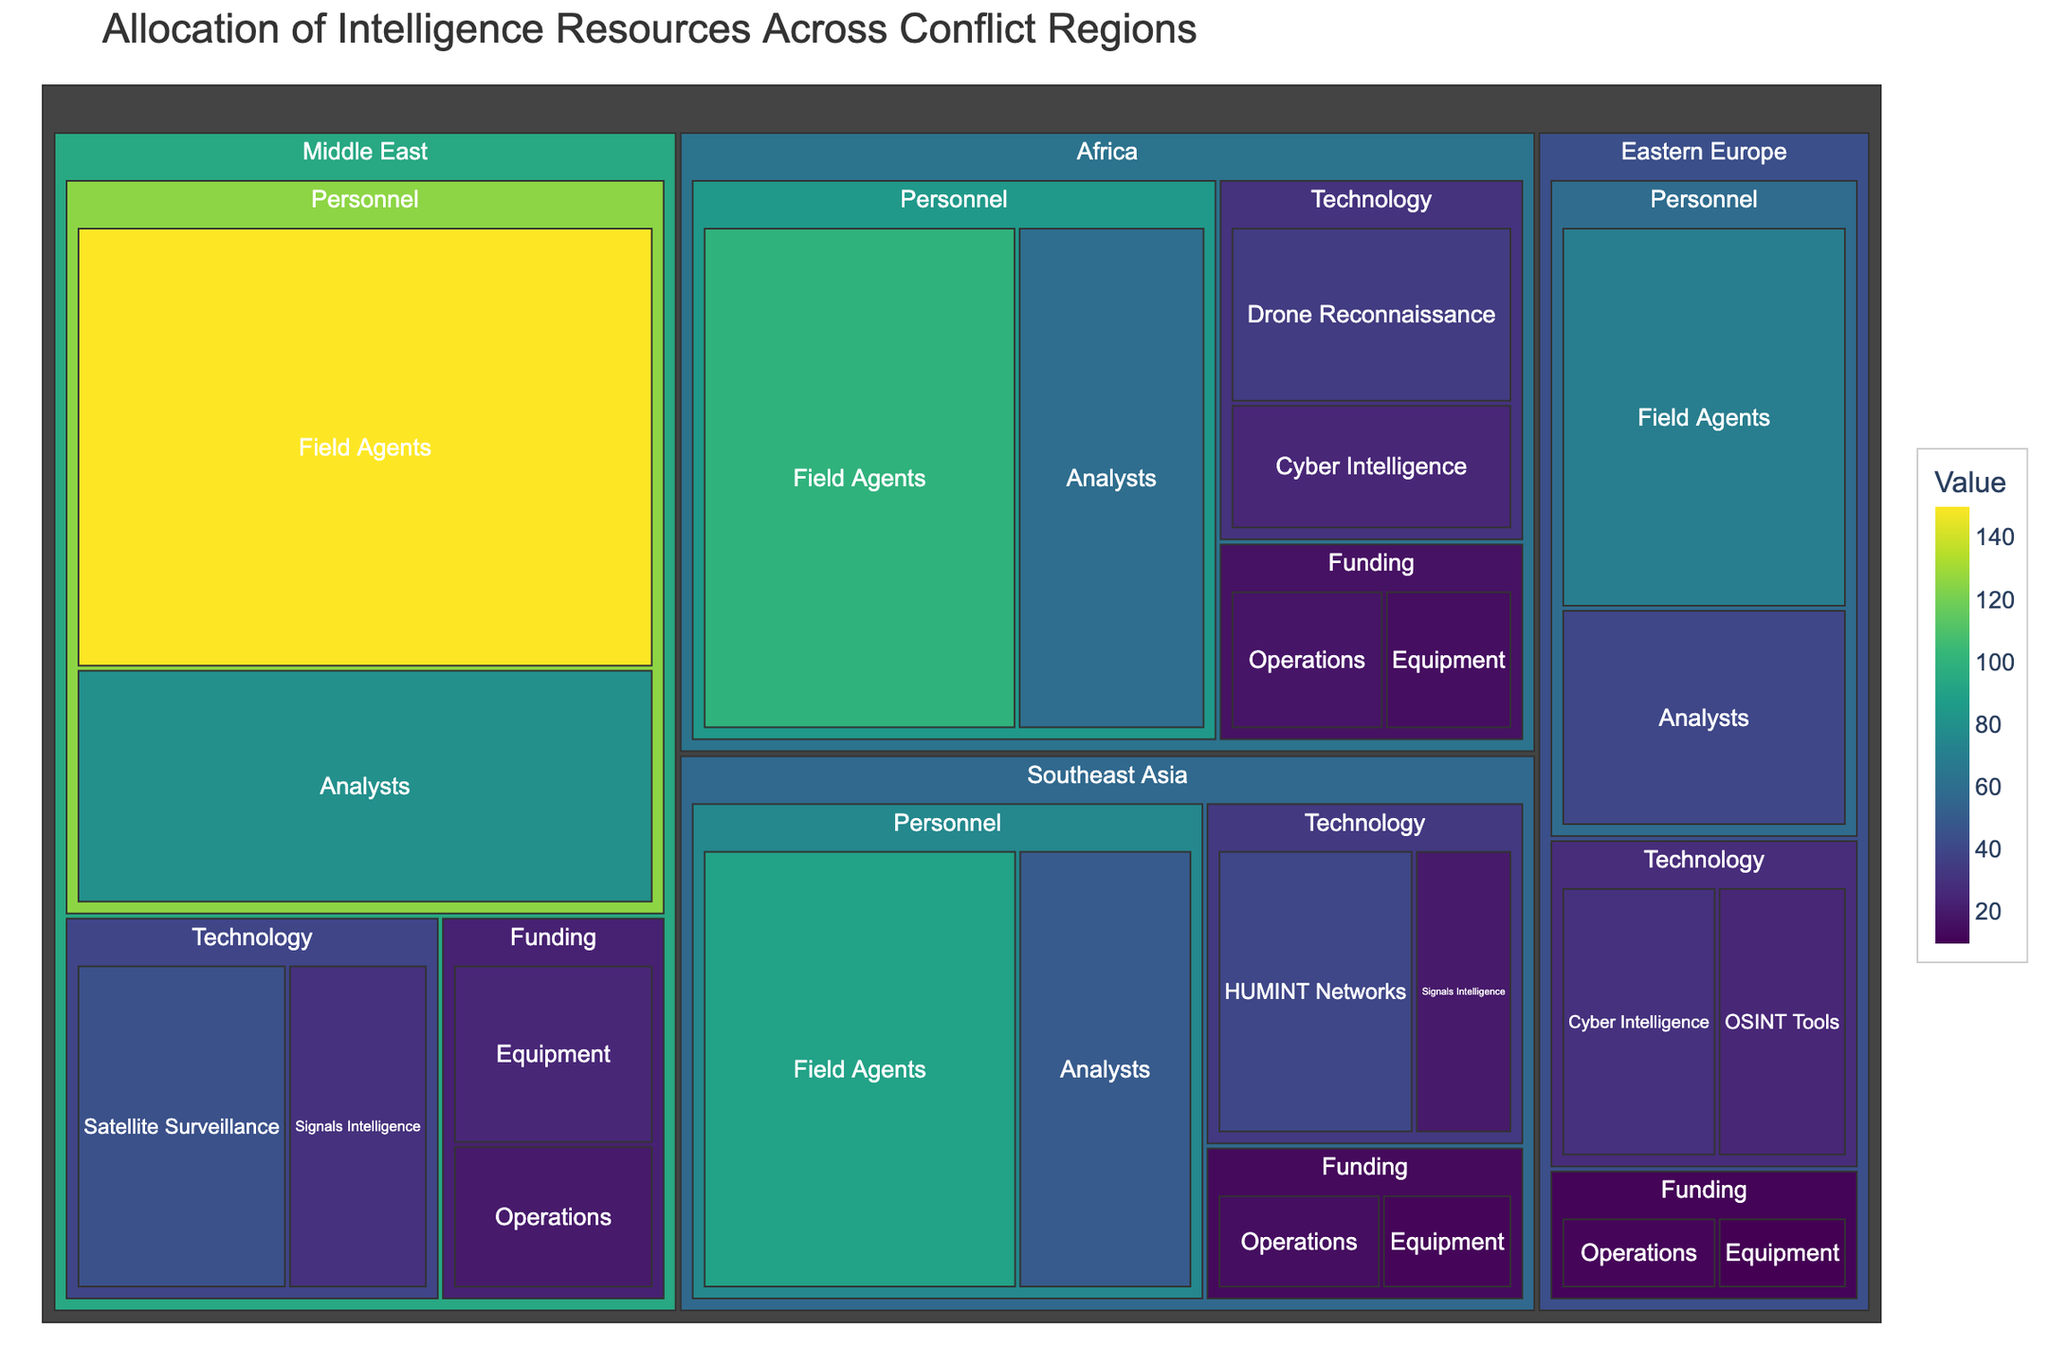What is the title of the treemap? The title of the figure is typically displayed at the top and provides a concise description of the content. Here, the title "Allocation of Intelligence Resources Across Conflict Regions" clearly explains what the figure represents.
Answer: Allocation of Intelligence Resources Across Conflict Regions What is the total value of personnel resources allocated in the Middle East? To determine this, sum the values of all personnel subcategories in the Middle East region: Field Agents (150) + Analysts (80).
Answer: 230 Which region has the highest allocation for Satellite Surveillance? By examining the 'Technology' category in each region, it's evident that only the Middle East has an allocation for Satellite Surveillance at 45.
Answer: Middle East Is the funding for operations in Southeast Asia higher or lower than in Africa? Compare the values in the 'Funding' category for operations: Southeast Asia has 15, and Africa has 18. Since 15 is less than 18, the funding is lower in Southeast Asia.
Answer: Lower Which region has the lowest allocation in the 'Funding' category? To find this, compare the sum of values within the 'Funding' category for each region. The sums are Middle East (45), Africa (33), Southeast Asia (27), and Eastern Europe (22). The lowest is Eastern Europe.
Answer: Eastern Europe How much more is allocated to Cyber Intelligence in Eastern Europe compared to Africa? Cyber Intelligence allocation in Eastern Europe is 30 and in Africa is 25. The difference is 30 - 25.
Answer: 5 What is the combined allocation for Analysts across all regions? Sum the values of Analysts in each region: Middle East (80), Africa (60), Southeast Asia (50), and Eastern Europe (40). The combined total is 80 + 60 + 50 + 40.
Answer: 230 Which category has the highest single subcategory value in Southeast Asia? Examine all subcategories in each category within Southeast Asia. The highest values are Field Agents (90) in 'Personnel,' HUMINT Networks (40) in 'Technology,' and Equipment (12) in 'Funding.' The highest among these is 90.
Answer: Personnel (Field Agents) What is the total resource allocation value for the Middle East? Sum all the subcategory values within the Middle East region: 150 (Field Agents) + 80 (Analysts) + 45 (Satellite Surveillance) + 30 (Signals Intelligence) + 25 (Equipment) + 20 (Operations).
Answer: 350 Comparing the allocations, is the 'Technology' resource higher in Africa or Southeast Asia? Sum 'Technology' subcategory values for Africa (35 + 25 = 60) and Southeast Asia (40 + 20 = 60). Both regions have the same allocation in 'Technology'.
Answer: Same 